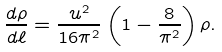<formula> <loc_0><loc_0><loc_500><loc_500>\frac { d \rho } { d \ell } = \frac { u ^ { 2 } } { 1 6 \pi ^ { 2 } } \left ( 1 - \frac { 8 } { \pi ^ { 2 } } \right ) \rho .</formula> 